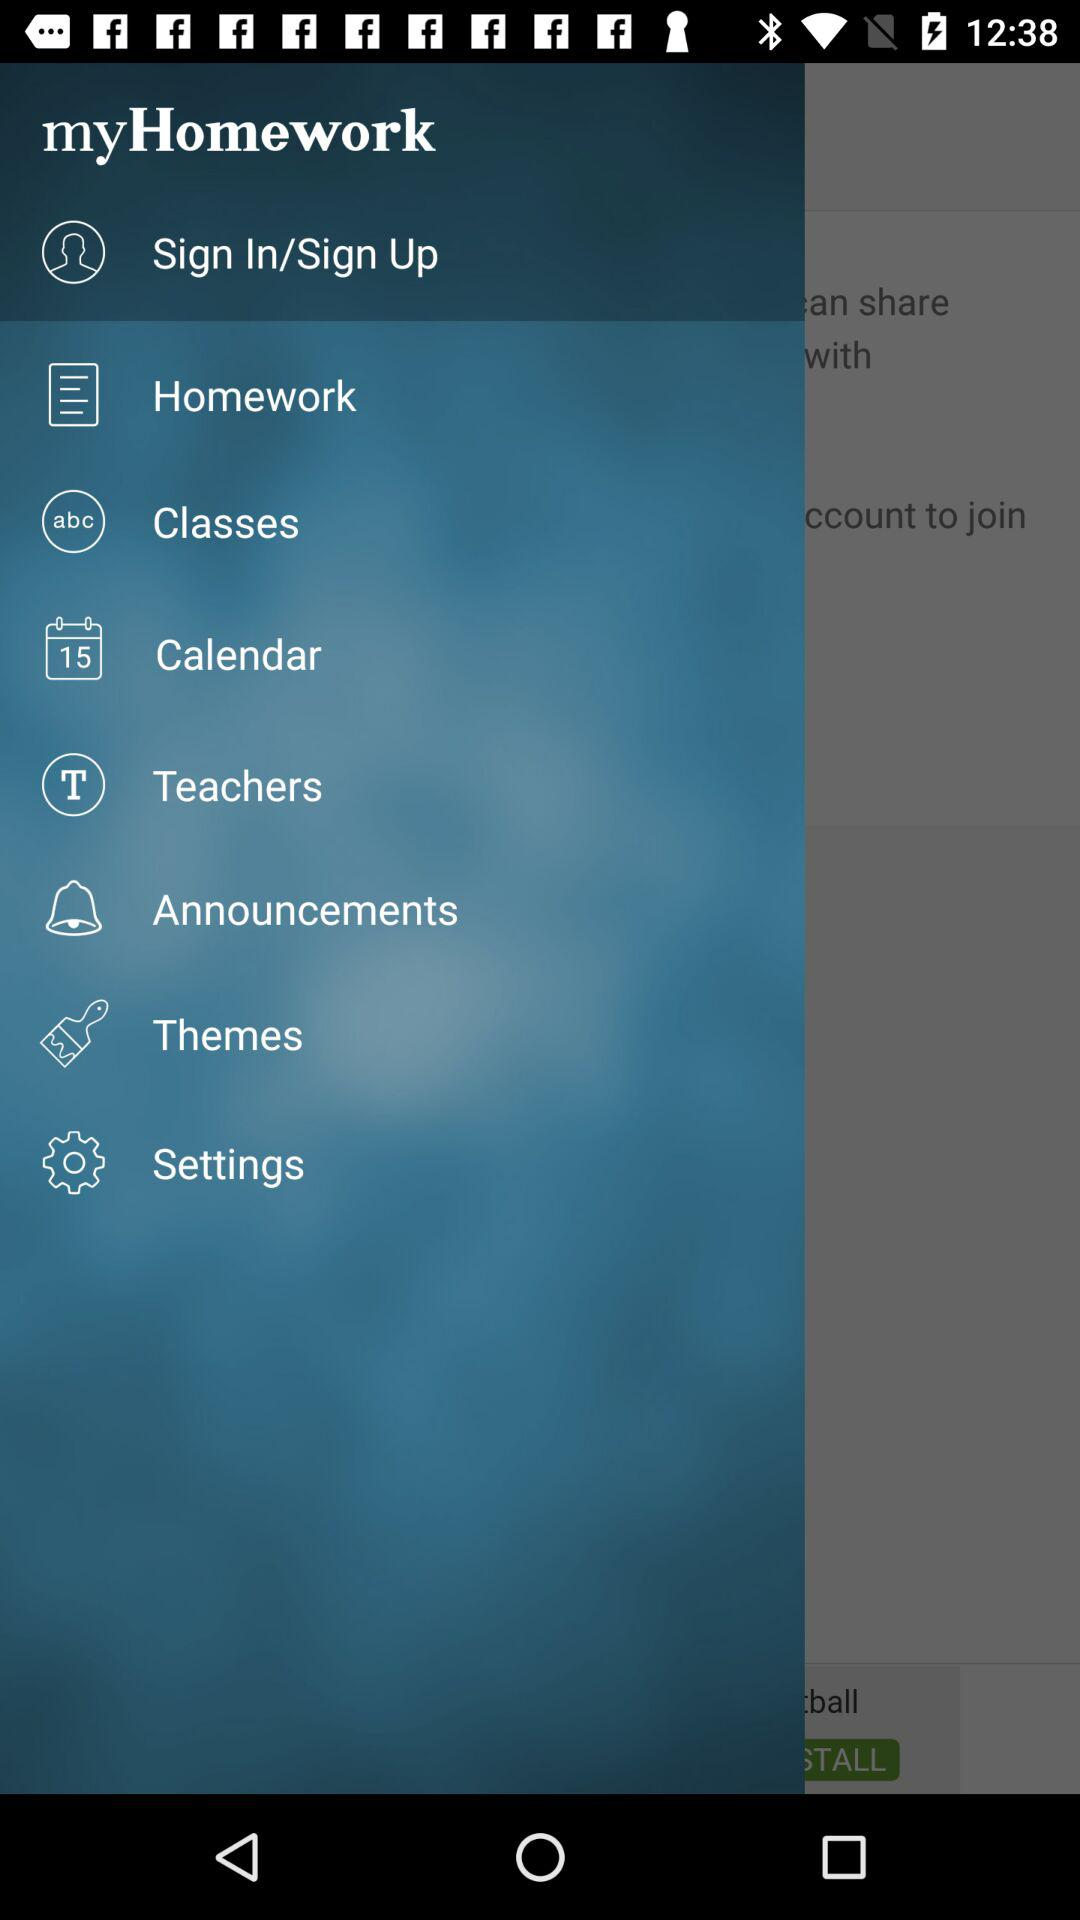What is the name of the application? The name of the application is "myHomework". 